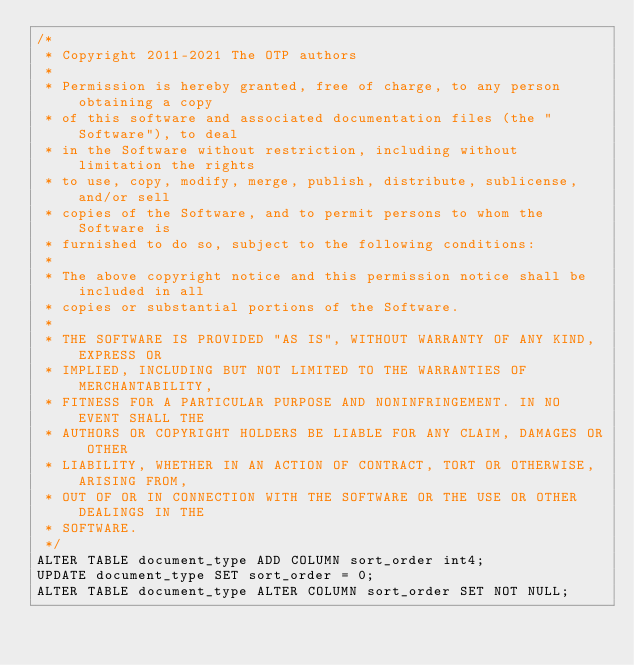Convert code to text. <code><loc_0><loc_0><loc_500><loc_500><_SQL_>/*
 * Copyright 2011-2021 The OTP authors
 *
 * Permission is hereby granted, free of charge, to any person obtaining a copy
 * of this software and associated documentation files (the "Software"), to deal
 * in the Software without restriction, including without limitation the rights
 * to use, copy, modify, merge, publish, distribute, sublicense, and/or sell
 * copies of the Software, and to permit persons to whom the Software is
 * furnished to do so, subject to the following conditions:
 *
 * The above copyright notice and this permission notice shall be included in all
 * copies or substantial portions of the Software.
 *
 * THE SOFTWARE IS PROVIDED "AS IS", WITHOUT WARRANTY OF ANY KIND, EXPRESS OR
 * IMPLIED, INCLUDING BUT NOT LIMITED TO THE WARRANTIES OF MERCHANTABILITY,
 * FITNESS FOR A PARTICULAR PURPOSE AND NONINFRINGEMENT. IN NO EVENT SHALL THE
 * AUTHORS OR COPYRIGHT HOLDERS BE LIABLE FOR ANY CLAIM, DAMAGES OR OTHER
 * LIABILITY, WHETHER IN AN ACTION OF CONTRACT, TORT OR OTHERWISE, ARISING FROM,
 * OUT OF OR IN CONNECTION WITH THE SOFTWARE OR THE USE OR OTHER DEALINGS IN THE
 * SOFTWARE.
 */
ALTER TABLE document_type ADD COLUMN sort_order int4;
UPDATE document_type SET sort_order = 0;
ALTER TABLE document_type ALTER COLUMN sort_order SET NOT NULL;
</code> 